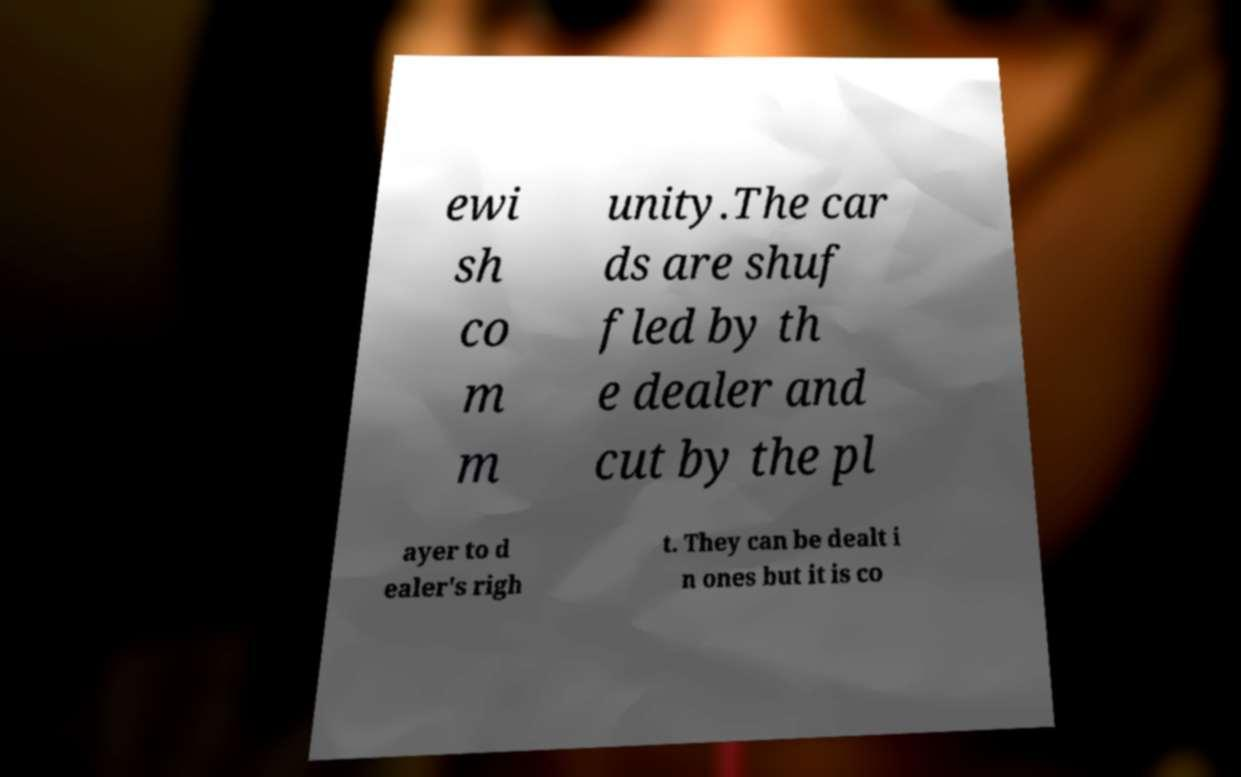For documentation purposes, I need the text within this image transcribed. Could you provide that? ewi sh co m m unity.The car ds are shuf fled by th e dealer and cut by the pl ayer to d ealer's righ t. They can be dealt i n ones but it is co 